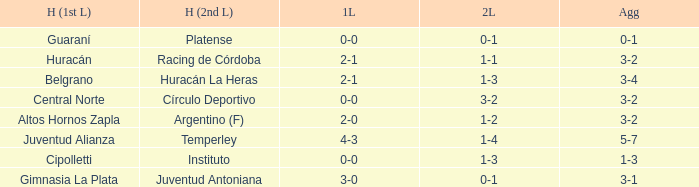What was the aggregate score that had a 1-2 second leg score? 3-2. 